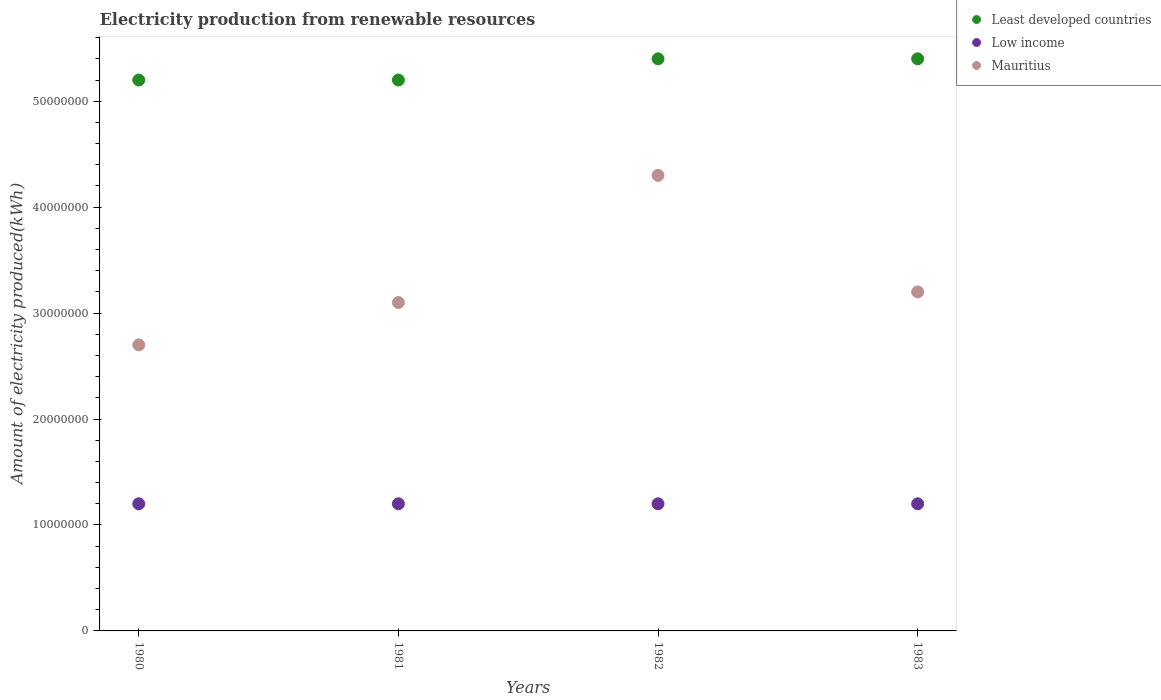How many different coloured dotlines are there?
Offer a very short reply. 3. Is the number of dotlines equal to the number of legend labels?
Make the answer very short. Yes. What is the amount of electricity produced in Low income in 1982?
Give a very brief answer. 1.20e+07. Across all years, what is the minimum amount of electricity produced in Least developed countries?
Offer a very short reply. 5.20e+07. In which year was the amount of electricity produced in Low income maximum?
Ensure brevity in your answer.  1980. In which year was the amount of electricity produced in Low income minimum?
Offer a terse response. 1980. What is the total amount of electricity produced in Low income in the graph?
Your response must be concise. 4.80e+07. What is the difference between the amount of electricity produced in Low income in 1982 and that in 1983?
Your answer should be very brief. 0. What is the difference between the amount of electricity produced in Low income in 1980 and the amount of electricity produced in Least developed countries in 1982?
Provide a succinct answer. -4.20e+07. What is the average amount of electricity produced in Least developed countries per year?
Make the answer very short. 5.30e+07. In the year 1981, what is the difference between the amount of electricity produced in Mauritius and amount of electricity produced in Low income?
Offer a terse response. 1.90e+07. What is the ratio of the amount of electricity produced in Mauritius in 1982 to that in 1983?
Your answer should be very brief. 1.34. What is the difference between the highest and the second highest amount of electricity produced in Mauritius?
Ensure brevity in your answer.  1.10e+07. In how many years, is the amount of electricity produced in Mauritius greater than the average amount of electricity produced in Mauritius taken over all years?
Your answer should be very brief. 1. Is the sum of the amount of electricity produced in Mauritius in 1982 and 1983 greater than the maximum amount of electricity produced in Low income across all years?
Offer a very short reply. Yes. Is it the case that in every year, the sum of the amount of electricity produced in Mauritius and amount of electricity produced in Low income  is greater than the amount of electricity produced in Least developed countries?
Ensure brevity in your answer.  No. Are the values on the major ticks of Y-axis written in scientific E-notation?
Ensure brevity in your answer.  No. Does the graph contain any zero values?
Provide a short and direct response. No. Where does the legend appear in the graph?
Your response must be concise. Top right. How many legend labels are there?
Keep it short and to the point. 3. What is the title of the graph?
Your answer should be very brief. Electricity production from renewable resources. What is the label or title of the X-axis?
Give a very brief answer. Years. What is the label or title of the Y-axis?
Your response must be concise. Amount of electricity produced(kWh). What is the Amount of electricity produced(kWh) of Least developed countries in 1980?
Your answer should be compact. 5.20e+07. What is the Amount of electricity produced(kWh) in Low income in 1980?
Offer a very short reply. 1.20e+07. What is the Amount of electricity produced(kWh) in Mauritius in 1980?
Keep it short and to the point. 2.70e+07. What is the Amount of electricity produced(kWh) in Least developed countries in 1981?
Your answer should be very brief. 5.20e+07. What is the Amount of electricity produced(kWh) of Mauritius in 1981?
Ensure brevity in your answer.  3.10e+07. What is the Amount of electricity produced(kWh) of Least developed countries in 1982?
Provide a succinct answer. 5.40e+07. What is the Amount of electricity produced(kWh) in Mauritius in 1982?
Offer a terse response. 4.30e+07. What is the Amount of electricity produced(kWh) in Least developed countries in 1983?
Provide a short and direct response. 5.40e+07. What is the Amount of electricity produced(kWh) of Low income in 1983?
Ensure brevity in your answer.  1.20e+07. What is the Amount of electricity produced(kWh) in Mauritius in 1983?
Make the answer very short. 3.20e+07. Across all years, what is the maximum Amount of electricity produced(kWh) of Least developed countries?
Ensure brevity in your answer.  5.40e+07. Across all years, what is the maximum Amount of electricity produced(kWh) in Low income?
Keep it short and to the point. 1.20e+07. Across all years, what is the maximum Amount of electricity produced(kWh) of Mauritius?
Offer a terse response. 4.30e+07. Across all years, what is the minimum Amount of electricity produced(kWh) of Least developed countries?
Ensure brevity in your answer.  5.20e+07. Across all years, what is the minimum Amount of electricity produced(kWh) of Mauritius?
Provide a succinct answer. 2.70e+07. What is the total Amount of electricity produced(kWh) of Least developed countries in the graph?
Offer a very short reply. 2.12e+08. What is the total Amount of electricity produced(kWh) in Low income in the graph?
Your answer should be very brief. 4.80e+07. What is the total Amount of electricity produced(kWh) in Mauritius in the graph?
Ensure brevity in your answer.  1.33e+08. What is the difference between the Amount of electricity produced(kWh) of Least developed countries in 1980 and that in 1982?
Your response must be concise. -2.00e+06. What is the difference between the Amount of electricity produced(kWh) in Mauritius in 1980 and that in 1982?
Offer a terse response. -1.60e+07. What is the difference between the Amount of electricity produced(kWh) of Least developed countries in 1980 and that in 1983?
Your answer should be very brief. -2.00e+06. What is the difference between the Amount of electricity produced(kWh) in Low income in 1980 and that in 1983?
Your answer should be compact. 0. What is the difference between the Amount of electricity produced(kWh) of Mauritius in 1980 and that in 1983?
Keep it short and to the point. -5.00e+06. What is the difference between the Amount of electricity produced(kWh) of Least developed countries in 1981 and that in 1982?
Ensure brevity in your answer.  -2.00e+06. What is the difference between the Amount of electricity produced(kWh) in Low income in 1981 and that in 1982?
Your answer should be compact. 0. What is the difference between the Amount of electricity produced(kWh) of Mauritius in 1981 and that in 1982?
Provide a succinct answer. -1.20e+07. What is the difference between the Amount of electricity produced(kWh) of Low income in 1981 and that in 1983?
Offer a very short reply. 0. What is the difference between the Amount of electricity produced(kWh) of Least developed countries in 1982 and that in 1983?
Keep it short and to the point. 0. What is the difference between the Amount of electricity produced(kWh) in Low income in 1982 and that in 1983?
Your answer should be very brief. 0. What is the difference between the Amount of electricity produced(kWh) of Mauritius in 1982 and that in 1983?
Provide a succinct answer. 1.10e+07. What is the difference between the Amount of electricity produced(kWh) in Least developed countries in 1980 and the Amount of electricity produced(kWh) in Low income in 1981?
Your answer should be compact. 4.00e+07. What is the difference between the Amount of electricity produced(kWh) in Least developed countries in 1980 and the Amount of electricity produced(kWh) in Mauritius in 1981?
Make the answer very short. 2.10e+07. What is the difference between the Amount of electricity produced(kWh) in Low income in 1980 and the Amount of electricity produced(kWh) in Mauritius in 1981?
Offer a terse response. -1.90e+07. What is the difference between the Amount of electricity produced(kWh) of Least developed countries in 1980 and the Amount of electricity produced(kWh) of Low income in 1982?
Your response must be concise. 4.00e+07. What is the difference between the Amount of electricity produced(kWh) of Least developed countries in 1980 and the Amount of electricity produced(kWh) of Mauritius in 1982?
Your answer should be very brief. 9.00e+06. What is the difference between the Amount of electricity produced(kWh) in Low income in 1980 and the Amount of electricity produced(kWh) in Mauritius in 1982?
Your answer should be compact. -3.10e+07. What is the difference between the Amount of electricity produced(kWh) of Least developed countries in 1980 and the Amount of electricity produced(kWh) of Low income in 1983?
Offer a very short reply. 4.00e+07. What is the difference between the Amount of electricity produced(kWh) in Least developed countries in 1980 and the Amount of electricity produced(kWh) in Mauritius in 1983?
Your answer should be very brief. 2.00e+07. What is the difference between the Amount of electricity produced(kWh) in Low income in 1980 and the Amount of electricity produced(kWh) in Mauritius in 1983?
Your response must be concise. -2.00e+07. What is the difference between the Amount of electricity produced(kWh) in Least developed countries in 1981 and the Amount of electricity produced(kWh) in Low income in 1982?
Provide a succinct answer. 4.00e+07. What is the difference between the Amount of electricity produced(kWh) of Least developed countries in 1981 and the Amount of electricity produced(kWh) of Mauritius in 1982?
Your answer should be very brief. 9.00e+06. What is the difference between the Amount of electricity produced(kWh) in Low income in 1981 and the Amount of electricity produced(kWh) in Mauritius in 1982?
Provide a short and direct response. -3.10e+07. What is the difference between the Amount of electricity produced(kWh) of Least developed countries in 1981 and the Amount of electricity produced(kWh) of Low income in 1983?
Provide a short and direct response. 4.00e+07. What is the difference between the Amount of electricity produced(kWh) in Low income in 1981 and the Amount of electricity produced(kWh) in Mauritius in 1983?
Your answer should be very brief. -2.00e+07. What is the difference between the Amount of electricity produced(kWh) of Least developed countries in 1982 and the Amount of electricity produced(kWh) of Low income in 1983?
Offer a very short reply. 4.20e+07. What is the difference between the Amount of electricity produced(kWh) of Least developed countries in 1982 and the Amount of electricity produced(kWh) of Mauritius in 1983?
Your answer should be compact. 2.20e+07. What is the difference between the Amount of electricity produced(kWh) of Low income in 1982 and the Amount of electricity produced(kWh) of Mauritius in 1983?
Give a very brief answer. -2.00e+07. What is the average Amount of electricity produced(kWh) in Least developed countries per year?
Keep it short and to the point. 5.30e+07. What is the average Amount of electricity produced(kWh) in Low income per year?
Offer a very short reply. 1.20e+07. What is the average Amount of electricity produced(kWh) in Mauritius per year?
Give a very brief answer. 3.32e+07. In the year 1980, what is the difference between the Amount of electricity produced(kWh) of Least developed countries and Amount of electricity produced(kWh) of Low income?
Ensure brevity in your answer.  4.00e+07. In the year 1980, what is the difference between the Amount of electricity produced(kWh) in Least developed countries and Amount of electricity produced(kWh) in Mauritius?
Offer a terse response. 2.50e+07. In the year 1980, what is the difference between the Amount of electricity produced(kWh) of Low income and Amount of electricity produced(kWh) of Mauritius?
Provide a succinct answer. -1.50e+07. In the year 1981, what is the difference between the Amount of electricity produced(kWh) of Least developed countries and Amount of electricity produced(kWh) of Low income?
Your response must be concise. 4.00e+07. In the year 1981, what is the difference between the Amount of electricity produced(kWh) of Least developed countries and Amount of electricity produced(kWh) of Mauritius?
Make the answer very short. 2.10e+07. In the year 1981, what is the difference between the Amount of electricity produced(kWh) of Low income and Amount of electricity produced(kWh) of Mauritius?
Provide a succinct answer. -1.90e+07. In the year 1982, what is the difference between the Amount of electricity produced(kWh) of Least developed countries and Amount of electricity produced(kWh) of Low income?
Give a very brief answer. 4.20e+07. In the year 1982, what is the difference between the Amount of electricity produced(kWh) of Least developed countries and Amount of electricity produced(kWh) of Mauritius?
Give a very brief answer. 1.10e+07. In the year 1982, what is the difference between the Amount of electricity produced(kWh) of Low income and Amount of electricity produced(kWh) of Mauritius?
Your answer should be compact. -3.10e+07. In the year 1983, what is the difference between the Amount of electricity produced(kWh) in Least developed countries and Amount of electricity produced(kWh) in Low income?
Give a very brief answer. 4.20e+07. In the year 1983, what is the difference between the Amount of electricity produced(kWh) in Least developed countries and Amount of electricity produced(kWh) in Mauritius?
Offer a very short reply. 2.20e+07. In the year 1983, what is the difference between the Amount of electricity produced(kWh) in Low income and Amount of electricity produced(kWh) in Mauritius?
Your answer should be very brief. -2.00e+07. What is the ratio of the Amount of electricity produced(kWh) in Low income in 1980 to that in 1981?
Give a very brief answer. 1. What is the ratio of the Amount of electricity produced(kWh) in Mauritius in 1980 to that in 1981?
Your response must be concise. 0.87. What is the ratio of the Amount of electricity produced(kWh) in Low income in 1980 to that in 1982?
Your answer should be compact. 1. What is the ratio of the Amount of electricity produced(kWh) of Mauritius in 1980 to that in 1982?
Your answer should be very brief. 0.63. What is the ratio of the Amount of electricity produced(kWh) of Least developed countries in 1980 to that in 1983?
Your answer should be compact. 0.96. What is the ratio of the Amount of electricity produced(kWh) in Low income in 1980 to that in 1983?
Provide a short and direct response. 1. What is the ratio of the Amount of electricity produced(kWh) of Mauritius in 1980 to that in 1983?
Provide a short and direct response. 0.84. What is the ratio of the Amount of electricity produced(kWh) of Low income in 1981 to that in 1982?
Keep it short and to the point. 1. What is the ratio of the Amount of electricity produced(kWh) of Mauritius in 1981 to that in 1982?
Ensure brevity in your answer.  0.72. What is the ratio of the Amount of electricity produced(kWh) of Least developed countries in 1981 to that in 1983?
Make the answer very short. 0.96. What is the ratio of the Amount of electricity produced(kWh) in Mauritius in 1981 to that in 1983?
Give a very brief answer. 0.97. What is the ratio of the Amount of electricity produced(kWh) in Least developed countries in 1982 to that in 1983?
Your answer should be very brief. 1. What is the ratio of the Amount of electricity produced(kWh) of Mauritius in 1982 to that in 1983?
Provide a succinct answer. 1.34. What is the difference between the highest and the second highest Amount of electricity produced(kWh) in Mauritius?
Provide a succinct answer. 1.10e+07. What is the difference between the highest and the lowest Amount of electricity produced(kWh) in Least developed countries?
Provide a succinct answer. 2.00e+06. What is the difference between the highest and the lowest Amount of electricity produced(kWh) in Mauritius?
Make the answer very short. 1.60e+07. 